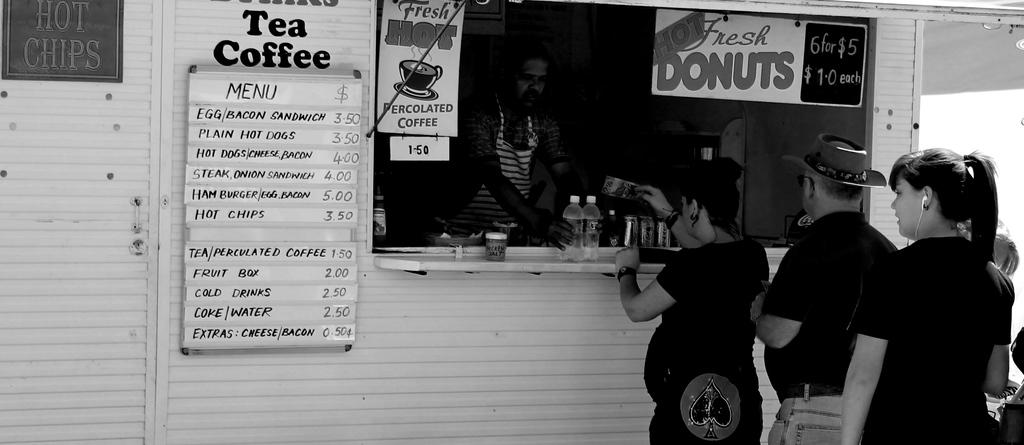What type of establishment is depicted in the image? There is a shop in the image. Are there any people near the shop? Yes, there are people in front of the shop. Can you describe the interior of the shop? There is a person inside the shop, and there is glass visible in the shop. What type of signage is present in the shop? There is a hoarding board in the shop. How can customers view the available items in the shop? There is a menu card attached to the wall of the shop. What type of fruit is being sold in the shop? There is no fruit visible in the image, and the type of items being sold is not mentioned. How many clams are displayed on the hoarding board? There are no clams present in the image, and the hoarding board does not display any clams. 